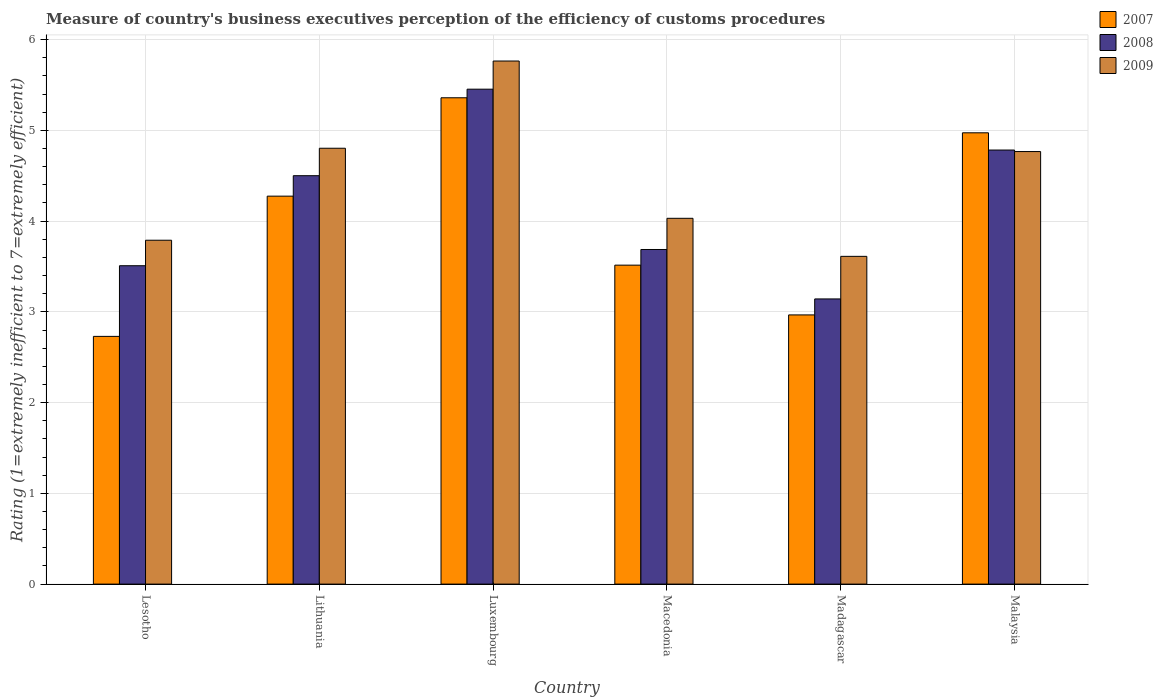How many groups of bars are there?
Make the answer very short. 6. Are the number of bars per tick equal to the number of legend labels?
Ensure brevity in your answer.  Yes. Are the number of bars on each tick of the X-axis equal?
Offer a terse response. Yes. How many bars are there on the 3rd tick from the left?
Keep it short and to the point. 3. What is the label of the 5th group of bars from the left?
Give a very brief answer. Madagascar. In how many cases, is the number of bars for a given country not equal to the number of legend labels?
Keep it short and to the point. 0. What is the rating of the efficiency of customs procedure in 2008 in Malaysia?
Your answer should be compact. 4.78. Across all countries, what is the maximum rating of the efficiency of customs procedure in 2008?
Ensure brevity in your answer.  5.45. Across all countries, what is the minimum rating of the efficiency of customs procedure in 2009?
Offer a terse response. 3.61. In which country was the rating of the efficiency of customs procedure in 2009 maximum?
Provide a short and direct response. Luxembourg. In which country was the rating of the efficiency of customs procedure in 2007 minimum?
Your answer should be compact. Lesotho. What is the total rating of the efficiency of customs procedure in 2007 in the graph?
Ensure brevity in your answer.  23.82. What is the difference between the rating of the efficiency of customs procedure in 2007 in Lithuania and that in Malaysia?
Offer a very short reply. -0.7. What is the difference between the rating of the efficiency of customs procedure in 2008 in Madagascar and the rating of the efficiency of customs procedure in 2009 in Lesotho?
Your answer should be compact. -0.65. What is the average rating of the efficiency of customs procedure in 2008 per country?
Ensure brevity in your answer.  4.18. What is the difference between the rating of the efficiency of customs procedure of/in 2007 and rating of the efficiency of customs procedure of/in 2008 in Macedonia?
Provide a short and direct response. -0.17. In how many countries, is the rating of the efficiency of customs procedure in 2008 greater than 0.8?
Ensure brevity in your answer.  6. What is the ratio of the rating of the efficiency of customs procedure in 2008 in Luxembourg to that in Madagascar?
Your response must be concise. 1.74. Is the rating of the efficiency of customs procedure in 2007 in Macedonia less than that in Malaysia?
Offer a very short reply. Yes. What is the difference between the highest and the second highest rating of the efficiency of customs procedure in 2008?
Provide a short and direct response. -0.28. What is the difference between the highest and the lowest rating of the efficiency of customs procedure in 2007?
Provide a short and direct response. 2.63. In how many countries, is the rating of the efficiency of customs procedure in 2008 greater than the average rating of the efficiency of customs procedure in 2008 taken over all countries?
Your answer should be very brief. 3. What does the 1st bar from the right in Macedonia represents?
Your response must be concise. 2009. Is it the case that in every country, the sum of the rating of the efficiency of customs procedure in 2008 and rating of the efficiency of customs procedure in 2009 is greater than the rating of the efficiency of customs procedure in 2007?
Your answer should be very brief. Yes. How many bars are there?
Ensure brevity in your answer.  18. Are all the bars in the graph horizontal?
Offer a very short reply. No. What is the difference between two consecutive major ticks on the Y-axis?
Ensure brevity in your answer.  1. Are the values on the major ticks of Y-axis written in scientific E-notation?
Provide a short and direct response. No. Does the graph contain any zero values?
Your response must be concise. No. Does the graph contain grids?
Ensure brevity in your answer.  Yes. Where does the legend appear in the graph?
Your response must be concise. Top right. How many legend labels are there?
Your answer should be very brief. 3. What is the title of the graph?
Your response must be concise. Measure of country's business executives perception of the efficiency of customs procedures. What is the label or title of the Y-axis?
Give a very brief answer. Rating (1=extremely inefficient to 7=extremely efficient). What is the Rating (1=extremely inefficient to 7=extremely efficient) in 2007 in Lesotho?
Your response must be concise. 2.73. What is the Rating (1=extremely inefficient to 7=extremely efficient) of 2008 in Lesotho?
Give a very brief answer. 3.51. What is the Rating (1=extremely inefficient to 7=extremely efficient) of 2009 in Lesotho?
Give a very brief answer. 3.79. What is the Rating (1=extremely inefficient to 7=extremely efficient) in 2007 in Lithuania?
Your answer should be compact. 4.28. What is the Rating (1=extremely inefficient to 7=extremely efficient) of 2008 in Lithuania?
Your response must be concise. 4.5. What is the Rating (1=extremely inefficient to 7=extremely efficient) of 2009 in Lithuania?
Keep it short and to the point. 4.8. What is the Rating (1=extremely inefficient to 7=extremely efficient) of 2007 in Luxembourg?
Your answer should be compact. 5.36. What is the Rating (1=extremely inefficient to 7=extremely efficient) of 2008 in Luxembourg?
Your answer should be compact. 5.45. What is the Rating (1=extremely inefficient to 7=extremely efficient) in 2009 in Luxembourg?
Your answer should be very brief. 5.76. What is the Rating (1=extremely inefficient to 7=extremely efficient) in 2007 in Macedonia?
Your answer should be very brief. 3.51. What is the Rating (1=extremely inefficient to 7=extremely efficient) of 2008 in Macedonia?
Keep it short and to the point. 3.69. What is the Rating (1=extremely inefficient to 7=extremely efficient) of 2009 in Macedonia?
Offer a terse response. 4.03. What is the Rating (1=extremely inefficient to 7=extremely efficient) in 2007 in Madagascar?
Your answer should be compact. 2.97. What is the Rating (1=extremely inefficient to 7=extremely efficient) in 2008 in Madagascar?
Your answer should be compact. 3.14. What is the Rating (1=extremely inefficient to 7=extremely efficient) of 2009 in Madagascar?
Your answer should be compact. 3.61. What is the Rating (1=extremely inefficient to 7=extremely efficient) of 2007 in Malaysia?
Ensure brevity in your answer.  4.97. What is the Rating (1=extremely inefficient to 7=extremely efficient) of 2008 in Malaysia?
Provide a succinct answer. 4.78. What is the Rating (1=extremely inefficient to 7=extremely efficient) in 2009 in Malaysia?
Give a very brief answer. 4.77. Across all countries, what is the maximum Rating (1=extremely inefficient to 7=extremely efficient) of 2007?
Offer a terse response. 5.36. Across all countries, what is the maximum Rating (1=extremely inefficient to 7=extremely efficient) of 2008?
Your answer should be very brief. 5.45. Across all countries, what is the maximum Rating (1=extremely inefficient to 7=extremely efficient) in 2009?
Make the answer very short. 5.76. Across all countries, what is the minimum Rating (1=extremely inefficient to 7=extremely efficient) in 2007?
Offer a very short reply. 2.73. Across all countries, what is the minimum Rating (1=extremely inefficient to 7=extremely efficient) in 2008?
Keep it short and to the point. 3.14. Across all countries, what is the minimum Rating (1=extremely inefficient to 7=extremely efficient) of 2009?
Provide a short and direct response. 3.61. What is the total Rating (1=extremely inefficient to 7=extremely efficient) of 2007 in the graph?
Provide a succinct answer. 23.82. What is the total Rating (1=extremely inefficient to 7=extremely efficient) of 2008 in the graph?
Your answer should be very brief. 25.07. What is the total Rating (1=extremely inefficient to 7=extremely efficient) of 2009 in the graph?
Give a very brief answer. 26.76. What is the difference between the Rating (1=extremely inefficient to 7=extremely efficient) in 2007 in Lesotho and that in Lithuania?
Provide a succinct answer. -1.55. What is the difference between the Rating (1=extremely inefficient to 7=extremely efficient) of 2008 in Lesotho and that in Lithuania?
Your answer should be compact. -0.99. What is the difference between the Rating (1=extremely inefficient to 7=extremely efficient) of 2009 in Lesotho and that in Lithuania?
Make the answer very short. -1.01. What is the difference between the Rating (1=extremely inefficient to 7=extremely efficient) of 2007 in Lesotho and that in Luxembourg?
Your response must be concise. -2.63. What is the difference between the Rating (1=extremely inefficient to 7=extremely efficient) of 2008 in Lesotho and that in Luxembourg?
Ensure brevity in your answer.  -1.95. What is the difference between the Rating (1=extremely inefficient to 7=extremely efficient) of 2009 in Lesotho and that in Luxembourg?
Your answer should be compact. -1.97. What is the difference between the Rating (1=extremely inefficient to 7=extremely efficient) in 2007 in Lesotho and that in Macedonia?
Your answer should be very brief. -0.78. What is the difference between the Rating (1=extremely inefficient to 7=extremely efficient) in 2008 in Lesotho and that in Macedonia?
Provide a short and direct response. -0.18. What is the difference between the Rating (1=extremely inefficient to 7=extremely efficient) of 2009 in Lesotho and that in Macedonia?
Make the answer very short. -0.24. What is the difference between the Rating (1=extremely inefficient to 7=extremely efficient) in 2007 in Lesotho and that in Madagascar?
Ensure brevity in your answer.  -0.24. What is the difference between the Rating (1=extremely inefficient to 7=extremely efficient) of 2008 in Lesotho and that in Madagascar?
Make the answer very short. 0.37. What is the difference between the Rating (1=extremely inefficient to 7=extremely efficient) of 2009 in Lesotho and that in Madagascar?
Your answer should be compact. 0.18. What is the difference between the Rating (1=extremely inefficient to 7=extremely efficient) of 2007 in Lesotho and that in Malaysia?
Offer a terse response. -2.24. What is the difference between the Rating (1=extremely inefficient to 7=extremely efficient) of 2008 in Lesotho and that in Malaysia?
Provide a succinct answer. -1.27. What is the difference between the Rating (1=extremely inefficient to 7=extremely efficient) in 2009 in Lesotho and that in Malaysia?
Keep it short and to the point. -0.98. What is the difference between the Rating (1=extremely inefficient to 7=extremely efficient) in 2007 in Lithuania and that in Luxembourg?
Your response must be concise. -1.08. What is the difference between the Rating (1=extremely inefficient to 7=extremely efficient) of 2008 in Lithuania and that in Luxembourg?
Your response must be concise. -0.95. What is the difference between the Rating (1=extremely inefficient to 7=extremely efficient) of 2009 in Lithuania and that in Luxembourg?
Your answer should be very brief. -0.96. What is the difference between the Rating (1=extremely inefficient to 7=extremely efficient) in 2007 in Lithuania and that in Macedonia?
Your answer should be compact. 0.76. What is the difference between the Rating (1=extremely inefficient to 7=extremely efficient) in 2008 in Lithuania and that in Macedonia?
Ensure brevity in your answer.  0.81. What is the difference between the Rating (1=extremely inefficient to 7=extremely efficient) of 2009 in Lithuania and that in Macedonia?
Make the answer very short. 0.77. What is the difference between the Rating (1=extremely inefficient to 7=extremely efficient) of 2007 in Lithuania and that in Madagascar?
Ensure brevity in your answer.  1.31. What is the difference between the Rating (1=extremely inefficient to 7=extremely efficient) in 2008 in Lithuania and that in Madagascar?
Keep it short and to the point. 1.36. What is the difference between the Rating (1=extremely inefficient to 7=extremely efficient) of 2009 in Lithuania and that in Madagascar?
Give a very brief answer. 1.19. What is the difference between the Rating (1=extremely inefficient to 7=extremely efficient) of 2007 in Lithuania and that in Malaysia?
Your answer should be compact. -0.7. What is the difference between the Rating (1=extremely inefficient to 7=extremely efficient) in 2008 in Lithuania and that in Malaysia?
Ensure brevity in your answer.  -0.28. What is the difference between the Rating (1=extremely inefficient to 7=extremely efficient) of 2009 in Lithuania and that in Malaysia?
Your response must be concise. 0.04. What is the difference between the Rating (1=extremely inefficient to 7=extremely efficient) of 2007 in Luxembourg and that in Macedonia?
Your answer should be compact. 1.84. What is the difference between the Rating (1=extremely inefficient to 7=extremely efficient) of 2008 in Luxembourg and that in Macedonia?
Provide a succinct answer. 1.77. What is the difference between the Rating (1=extremely inefficient to 7=extremely efficient) of 2009 in Luxembourg and that in Macedonia?
Offer a very short reply. 1.73. What is the difference between the Rating (1=extremely inefficient to 7=extremely efficient) of 2007 in Luxembourg and that in Madagascar?
Provide a succinct answer. 2.39. What is the difference between the Rating (1=extremely inefficient to 7=extremely efficient) in 2008 in Luxembourg and that in Madagascar?
Ensure brevity in your answer.  2.31. What is the difference between the Rating (1=extremely inefficient to 7=extremely efficient) in 2009 in Luxembourg and that in Madagascar?
Offer a terse response. 2.15. What is the difference between the Rating (1=extremely inefficient to 7=extremely efficient) of 2007 in Luxembourg and that in Malaysia?
Keep it short and to the point. 0.39. What is the difference between the Rating (1=extremely inefficient to 7=extremely efficient) of 2008 in Luxembourg and that in Malaysia?
Make the answer very short. 0.67. What is the difference between the Rating (1=extremely inefficient to 7=extremely efficient) of 2009 in Luxembourg and that in Malaysia?
Your answer should be very brief. 1. What is the difference between the Rating (1=extremely inefficient to 7=extremely efficient) in 2007 in Macedonia and that in Madagascar?
Keep it short and to the point. 0.55. What is the difference between the Rating (1=extremely inefficient to 7=extremely efficient) in 2008 in Macedonia and that in Madagascar?
Offer a terse response. 0.54. What is the difference between the Rating (1=extremely inefficient to 7=extremely efficient) in 2009 in Macedonia and that in Madagascar?
Provide a succinct answer. 0.42. What is the difference between the Rating (1=extremely inefficient to 7=extremely efficient) of 2007 in Macedonia and that in Malaysia?
Keep it short and to the point. -1.46. What is the difference between the Rating (1=extremely inefficient to 7=extremely efficient) in 2008 in Macedonia and that in Malaysia?
Offer a terse response. -1.1. What is the difference between the Rating (1=extremely inefficient to 7=extremely efficient) in 2009 in Macedonia and that in Malaysia?
Provide a short and direct response. -0.74. What is the difference between the Rating (1=extremely inefficient to 7=extremely efficient) of 2007 in Madagascar and that in Malaysia?
Offer a terse response. -2.01. What is the difference between the Rating (1=extremely inefficient to 7=extremely efficient) in 2008 in Madagascar and that in Malaysia?
Keep it short and to the point. -1.64. What is the difference between the Rating (1=extremely inefficient to 7=extremely efficient) of 2009 in Madagascar and that in Malaysia?
Give a very brief answer. -1.15. What is the difference between the Rating (1=extremely inefficient to 7=extremely efficient) of 2007 in Lesotho and the Rating (1=extremely inefficient to 7=extremely efficient) of 2008 in Lithuania?
Provide a succinct answer. -1.77. What is the difference between the Rating (1=extremely inefficient to 7=extremely efficient) of 2007 in Lesotho and the Rating (1=extremely inefficient to 7=extremely efficient) of 2009 in Lithuania?
Offer a very short reply. -2.07. What is the difference between the Rating (1=extremely inefficient to 7=extremely efficient) in 2008 in Lesotho and the Rating (1=extremely inefficient to 7=extremely efficient) in 2009 in Lithuania?
Give a very brief answer. -1.29. What is the difference between the Rating (1=extremely inefficient to 7=extremely efficient) in 2007 in Lesotho and the Rating (1=extremely inefficient to 7=extremely efficient) in 2008 in Luxembourg?
Give a very brief answer. -2.72. What is the difference between the Rating (1=extremely inefficient to 7=extremely efficient) in 2007 in Lesotho and the Rating (1=extremely inefficient to 7=extremely efficient) in 2009 in Luxembourg?
Your answer should be compact. -3.03. What is the difference between the Rating (1=extremely inefficient to 7=extremely efficient) in 2008 in Lesotho and the Rating (1=extremely inefficient to 7=extremely efficient) in 2009 in Luxembourg?
Your response must be concise. -2.26. What is the difference between the Rating (1=extremely inefficient to 7=extremely efficient) of 2007 in Lesotho and the Rating (1=extremely inefficient to 7=extremely efficient) of 2008 in Macedonia?
Ensure brevity in your answer.  -0.96. What is the difference between the Rating (1=extremely inefficient to 7=extremely efficient) in 2007 in Lesotho and the Rating (1=extremely inefficient to 7=extremely efficient) in 2009 in Macedonia?
Provide a succinct answer. -1.3. What is the difference between the Rating (1=extremely inefficient to 7=extremely efficient) in 2008 in Lesotho and the Rating (1=extremely inefficient to 7=extremely efficient) in 2009 in Macedonia?
Make the answer very short. -0.52. What is the difference between the Rating (1=extremely inefficient to 7=extremely efficient) of 2007 in Lesotho and the Rating (1=extremely inefficient to 7=extremely efficient) of 2008 in Madagascar?
Provide a succinct answer. -0.41. What is the difference between the Rating (1=extremely inefficient to 7=extremely efficient) in 2007 in Lesotho and the Rating (1=extremely inefficient to 7=extremely efficient) in 2009 in Madagascar?
Ensure brevity in your answer.  -0.88. What is the difference between the Rating (1=extremely inefficient to 7=extremely efficient) of 2008 in Lesotho and the Rating (1=extremely inefficient to 7=extremely efficient) of 2009 in Madagascar?
Provide a short and direct response. -0.1. What is the difference between the Rating (1=extremely inefficient to 7=extremely efficient) of 2007 in Lesotho and the Rating (1=extremely inefficient to 7=extremely efficient) of 2008 in Malaysia?
Your answer should be very brief. -2.05. What is the difference between the Rating (1=extremely inefficient to 7=extremely efficient) of 2007 in Lesotho and the Rating (1=extremely inefficient to 7=extremely efficient) of 2009 in Malaysia?
Make the answer very short. -2.04. What is the difference between the Rating (1=extremely inefficient to 7=extremely efficient) of 2008 in Lesotho and the Rating (1=extremely inefficient to 7=extremely efficient) of 2009 in Malaysia?
Make the answer very short. -1.26. What is the difference between the Rating (1=extremely inefficient to 7=extremely efficient) in 2007 in Lithuania and the Rating (1=extremely inefficient to 7=extremely efficient) in 2008 in Luxembourg?
Give a very brief answer. -1.18. What is the difference between the Rating (1=extremely inefficient to 7=extremely efficient) in 2007 in Lithuania and the Rating (1=extremely inefficient to 7=extremely efficient) in 2009 in Luxembourg?
Ensure brevity in your answer.  -1.49. What is the difference between the Rating (1=extremely inefficient to 7=extremely efficient) in 2008 in Lithuania and the Rating (1=extremely inefficient to 7=extremely efficient) in 2009 in Luxembourg?
Your response must be concise. -1.26. What is the difference between the Rating (1=extremely inefficient to 7=extremely efficient) of 2007 in Lithuania and the Rating (1=extremely inefficient to 7=extremely efficient) of 2008 in Macedonia?
Make the answer very short. 0.59. What is the difference between the Rating (1=extremely inefficient to 7=extremely efficient) in 2007 in Lithuania and the Rating (1=extremely inefficient to 7=extremely efficient) in 2009 in Macedonia?
Your answer should be very brief. 0.24. What is the difference between the Rating (1=extremely inefficient to 7=extremely efficient) in 2008 in Lithuania and the Rating (1=extremely inefficient to 7=extremely efficient) in 2009 in Macedonia?
Offer a very short reply. 0.47. What is the difference between the Rating (1=extremely inefficient to 7=extremely efficient) of 2007 in Lithuania and the Rating (1=extremely inefficient to 7=extremely efficient) of 2008 in Madagascar?
Provide a succinct answer. 1.13. What is the difference between the Rating (1=extremely inefficient to 7=extremely efficient) of 2007 in Lithuania and the Rating (1=extremely inefficient to 7=extremely efficient) of 2009 in Madagascar?
Make the answer very short. 0.66. What is the difference between the Rating (1=extremely inefficient to 7=extremely efficient) in 2008 in Lithuania and the Rating (1=extremely inefficient to 7=extremely efficient) in 2009 in Madagascar?
Provide a short and direct response. 0.89. What is the difference between the Rating (1=extremely inefficient to 7=extremely efficient) in 2007 in Lithuania and the Rating (1=extremely inefficient to 7=extremely efficient) in 2008 in Malaysia?
Your answer should be very brief. -0.51. What is the difference between the Rating (1=extremely inefficient to 7=extremely efficient) in 2007 in Lithuania and the Rating (1=extremely inefficient to 7=extremely efficient) in 2009 in Malaysia?
Make the answer very short. -0.49. What is the difference between the Rating (1=extremely inefficient to 7=extremely efficient) of 2008 in Lithuania and the Rating (1=extremely inefficient to 7=extremely efficient) of 2009 in Malaysia?
Offer a terse response. -0.27. What is the difference between the Rating (1=extremely inefficient to 7=extremely efficient) in 2007 in Luxembourg and the Rating (1=extremely inefficient to 7=extremely efficient) in 2008 in Macedonia?
Offer a very short reply. 1.67. What is the difference between the Rating (1=extremely inefficient to 7=extremely efficient) of 2007 in Luxembourg and the Rating (1=extremely inefficient to 7=extremely efficient) of 2009 in Macedonia?
Offer a terse response. 1.33. What is the difference between the Rating (1=extremely inefficient to 7=extremely efficient) in 2008 in Luxembourg and the Rating (1=extremely inefficient to 7=extremely efficient) in 2009 in Macedonia?
Your response must be concise. 1.42. What is the difference between the Rating (1=extremely inefficient to 7=extremely efficient) in 2007 in Luxembourg and the Rating (1=extremely inefficient to 7=extremely efficient) in 2008 in Madagascar?
Your answer should be compact. 2.22. What is the difference between the Rating (1=extremely inefficient to 7=extremely efficient) in 2007 in Luxembourg and the Rating (1=extremely inefficient to 7=extremely efficient) in 2009 in Madagascar?
Provide a succinct answer. 1.75. What is the difference between the Rating (1=extremely inefficient to 7=extremely efficient) of 2008 in Luxembourg and the Rating (1=extremely inefficient to 7=extremely efficient) of 2009 in Madagascar?
Your answer should be very brief. 1.84. What is the difference between the Rating (1=extremely inefficient to 7=extremely efficient) of 2007 in Luxembourg and the Rating (1=extremely inefficient to 7=extremely efficient) of 2008 in Malaysia?
Provide a short and direct response. 0.58. What is the difference between the Rating (1=extremely inefficient to 7=extremely efficient) in 2007 in Luxembourg and the Rating (1=extremely inefficient to 7=extremely efficient) in 2009 in Malaysia?
Ensure brevity in your answer.  0.59. What is the difference between the Rating (1=extremely inefficient to 7=extremely efficient) of 2008 in Luxembourg and the Rating (1=extremely inefficient to 7=extremely efficient) of 2009 in Malaysia?
Offer a terse response. 0.69. What is the difference between the Rating (1=extremely inefficient to 7=extremely efficient) of 2007 in Macedonia and the Rating (1=extremely inefficient to 7=extremely efficient) of 2008 in Madagascar?
Make the answer very short. 0.37. What is the difference between the Rating (1=extremely inefficient to 7=extremely efficient) in 2007 in Macedonia and the Rating (1=extremely inefficient to 7=extremely efficient) in 2009 in Madagascar?
Offer a terse response. -0.1. What is the difference between the Rating (1=extremely inefficient to 7=extremely efficient) in 2008 in Macedonia and the Rating (1=extremely inefficient to 7=extremely efficient) in 2009 in Madagascar?
Your answer should be very brief. 0.08. What is the difference between the Rating (1=extremely inefficient to 7=extremely efficient) in 2007 in Macedonia and the Rating (1=extremely inefficient to 7=extremely efficient) in 2008 in Malaysia?
Provide a short and direct response. -1.27. What is the difference between the Rating (1=extremely inefficient to 7=extremely efficient) in 2007 in Macedonia and the Rating (1=extremely inefficient to 7=extremely efficient) in 2009 in Malaysia?
Offer a terse response. -1.25. What is the difference between the Rating (1=extremely inefficient to 7=extremely efficient) of 2008 in Macedonia and the Rating (1=extremely inefficient to 7=extremely efficient) of 2009 in Malaysia?
Your answer should be very brief. -1.08. What is the difference between the Rating (1=extremely inefficient to 7=extremely efficient) in 2007 in Madagascar and the Rating (1=extremely inefficient to 7=extremely efficient) in 2008 in Malaysia?
Your answer should be compact. -1.82. What is the difference between the Rating (1=extremely inefficient to 7=extremely efficient) in 2007 in Madagascar and the Rating (1=extremely inefficient to 7=extremely efficient) in 2009 in Malaysia?
Your answer should be very brief. -1.8. What is the difference between the Rating (1=extremely inefficient to 7=extremely efficient) in 2008 in Madagascar and the Rating (1=extremely inefficient to 7=extremely efficient) in 2009 in Malaysia?
Offer a terse response. -1.62. What is the average Rating (1=extremely inefficient to 7=extremely efficient) of 2007 per country?
Make the answer very short. 3.97. What is the average Rating (1=extremely inefficient to 7=extremely efficient) of 2008 per country?
Provide a succinct answer. 4.18. What is the average Rating (1=extremely inefficient to 7=extremely efficient) in 2009 per country?
Provide a succinct answer. 4.46. What is the difference between the Rating (1=extremely inefficient to 7=extremely efficient) in 2007 and Rating (1=extremely inefficient to 7=extremely efficient) in 2008 in Lesotho?
Offer a terse response. -0.78. What is the difference between the Rating (1=extremely inefficient to 7=extremely efficient) of 2007 and Rating (1=extremely inefficient to 7=extremely efficient) of 2009 in Lesotho?
Offer a terse response. -1.06. What is the difference between the Rating (1=extremely inefficient to 7=extremely efficient) in 2008 and Rating (1=extremely inefficient to 7=extremely efficient) in 2009 in Lesotho?
Offer a terse response. -0.28. What is the difference between the Rating (1=extremely inefficient to 7=extremely efficient) in 2007 and Rating (1=extremely inefficient to 7=extremely efficient) in 2008 in Lithuania?
Ensure brevity in your answer.  -0.23. What is the difference between the Rating (1=extremely inefficient to 7=extremely efficient) in 2007 and Rating (1=extremely inefficient to 7=extremely efficient) in 2009 in Lithuania?
Offer a terse response. -0.53. What is the difference between the Rating (1=extremely inefficient to 7=extremely efficient) of 2008 and Rating (1=extremely inefficient to 7=extremely efficient) of 2009 in Lithuania?
Your answer should be compact. -0.3. What is the difference between the Rating (1=extremely inefficient to 7=extremely efficient) in 2007 and Rating (1=extremely inefficient to 7=extremely efficient) in 2008 in Luxembourg?
Provide a short and direct response. -0.09. What is the difference between the Rating (1=extremely inefficient to 7=extremely efficient) in 2007 and Rating (1=extremely inefficient to 7=extremely efficient) in 2009 in Luxembourg?
Your response must be concise. -0.4. What is the difference between the Rating (1=extremely inefficient to 7=extremely efficient) in 2008 and Rating (1=extremely inefficient to 7=extremely efficient) in 2009 in Luxembourg?
Your answer should be compact. -0.31. What is the difference between the Rating (1=extremely inefficient to 7=extremely efficient) in 2007 and Rating (1=extremely inefficient to 7=extremely efficient) in 2008 in Macedonia?
Offer a terse response. -0.17. What is the difference between the Rating (1=extremely inefficient to 7=extremely efficient) in 2007 and Rating (1=extremely inefficient to 7=extremely efficient) in 2009 in Macedonia?
Your response must be concise. -0.52. What is the difference between the Rating (1=extremely inefficient to 7=extremely efficient) in 2008 and Rating (1=extremely inefficient to 7=extremely efficient) in 2009 in Macedonia?
Your response must be concise. -0.34. What is the difference between the Rating (1=extremely inefficient to 7=extremely efficient) of 2007 and Rating (1=extremely inefficient to 7=extremely efficient) of 2008 in Madagascar?
Make the answer very short. -0.18. What is the difference between the Rating (1=extremely inefficient to 7=extremely efficient) of 2007 and Rating (1=extremely inefficient to 7=extremely efficient) of 2009 in Madagascar?
Offer a very short reply. -0.65. What is the difference between the Rating (1=extremely inefficient to 7=extremely efficient) of 2008 and Rating (1=extremely inefficient to 7=extremely efficient) of 2009 in Madagascar?
Ensure brevity in your answer.  -0.47. What is the difference between the Rating (1=extremely inefficient to 7=extremely efficient) in 2007 and Rating (1=extremely inefficient to 7=extremely efficient) in 2008 in Malaysia?
Offer a terse response. 0.19. What is the difference between the Rating (1=extremely inefficient to 7=extremely efficient) of 2007 and Rating (1=extremely inefficient to 7=extremely efficient) of 2009 in Malaysia?
Provide a short and direct response. 0.21. What is the difference between the Rating (1=extremely inefficient to 7=extremely efficient) of 2008 and Rating (1=extremely inefficient to 7=extremely efficient) of 2009 in Malaysia?
Ensure brevity in your answer.  0.02. What is the ratio of the Rating (1=extremely inefficient to 7=extremely efficient) in 2007 in Lesotho to that in Lithuania?
Offer a terse response. 0.64. What is the ratio of the Rating (1=extremely inefficient to 7=extremely efficient) in 2008 in Lesotho to that in Lithuania?
Ensure brevity in your answer.  0.78. What is the ratio of the Rating (1=extremely inefficient to 7=extremely efficient) in 2009 in Lesotho to that in Lithuania?
Give a very brief answer. 0.79. What is the ratio of the Rating (1=extremely inefficient to 7=extremely efficient) of 2007 in Lesotho to that in Luxembourg?
Ensure brevity in your answer.  0.51. What is the ratio of the Rating (1=extremely inefficient to 7=extremely efficient) of 2008 in Lesotho to that in Luxembourg?
Keep it short and to the point. 0.64. What is the ratio of the Rating (1=extremely inefficient to 7=extremely efficient) of 2009 in Lesotho to that in Luxembourg?
Provide a succinct answer. 0.66. What is the ratio of the Rating (1=extremely inefficient to 7=extremely efficient) of 2007 in Lesotho to that in Macedonia?
Make the answer very short. 0.78. What is the ratio of the Rating (1=extremely inefficient to 7=extremely efficient) of 2008 in Lesotho to that in Macedonia?
Provide a succinct answer. 0.95. What is the ratio of the Rating (1=extremely inefficient to 7=extremely efficient) of 2009 in Lesotho to that in Macedonia?
Make the answer very short. 0.94. What is the ratio of the Rating (1=extremely inefficient to 7=extremely efficient) in 2007 in Lesotho to that in Madagascar?
Keep it short and to the point. 0.92. What is the ratio of the Rating (1=extremely inefficient to 7=extremely efficient) of 2008 in Lesotho to that in Madagascar?
Your response must be concise. 1.12. What is the ratio of the Rating (1=extremely inefficient to 7=extremely efficient) of 2009 in Lesotho to that in Madagascar?
Offer a very short reply. 1.05. What is the ratio of the Rating (1=extremely inefficient to 7=extremely efficient) in 2007 in Lesotho to that in Malaysia?
Provide a short and direct response. 0.55. What is the ratio of the Rating (1=extremely inefficient to 7=extremely efficient) of 2008 in Lesotho to that in Malaysia?
Your response must be concise. 0.73. What is the ratio of the Rating (1=extremely inefficient to 7=extremely efficient) of 2009 in Lesotho to that in Malaysia?
Offer a terse response. 0.8. What is the ratio of the Rating (1=extremely inefficient to 7=extremely efficient) of 2007 in Lithuania to that in Luxembourg?
Your answer should be compact. 0.8. What is the ratio of the Rating (1=extremely inefficient to 7=extremely efficient) of 2008 in Lithuania to that in Luxembourg?
Offer a very short reply. 0.83. What is the ratio of the Rating (1=extremely inefficient to 7=extremely efficient) of 2009 in Lithuania to that in Luxembourg?
Provide a short and direct response. 0.83. What is the ratio of the Rating (1=extremely inefficient to 7=extremely efficient) in 2007 in Lithuania to that in Macedonia?
Offer a terse response. 1.22. What is the ratio of the Rating (1=extremely inefficient to 7=extremely efficient) of 2008 in Lithuania to that in Macedonia?
Provide a short and direct response. 1.22. What is the ratio of the Rating (1=extremely inefficient to 7=extremely efficient) of 2009 in Lithuania to that in Macedonia?
Give a very brief answer. 1.19. What is the ratio of the Rating (1=extremely inefficient to 7=extremely efficient) in 2007 in Lithuania to that in Madagascar?
Your response must be concise. 1.44. What is the ratio of the Rating (1=extremely inefficient to 7=extremely efficient) of 2008 in Lithuania to that in Madagascar?
Offer a very short reply. 1.43. What is the ratio of the Rating (1=extremely inefficient to 7=extremely efficient) in 2009 in Lithuania to that in Madagascar?
Your response must be concise. 1.33. What is the ratio of the Rating (1=extremely inefficient to 7=extremely efficient) of 2007 in Lithuania to that in Malaysia?
Your answer should be very brief. 0.86. What is the ratio of the Rating (1=extremely inefficient to 7=extremely efficient) in 2008 in Lithuania to that in Malaysia?
Ensure brevity in your answer.  0.94. What is the ratio of the Rating (1=extremely inefficient to 7=extremely efficient) of 2009 in Lithuania to that in Malaysia?
Your response must be concise. 1.01. What is the ratio of the Rating (1=extremely inefficient to 7=extremely efficient) in 2007 in Luxembourg to that in Macedonia?
Your answer should be compact. 1.52. What is the ratio of the Rating (1=extremely inefficient to 7=extremely efficient) of 2008 in Luxembourg to that in Macedonia?
Provide a succinct answer. 1.48. What is the ratio of the Rating (1=extremely inefficient to 7=extremely efficient) in 2009 in Luxembourg to that in Macedonia?
Your response must be concise. 1.43. What is the ratio of the Rating (1=extremely inefficient to 7=extremely efficient) in 2007 in Luxembourg to that in Madagascar?
Make the answer very short. 1.81. What is the ratio of the Rating (1=extremely inefficient to 7=extremely efficient) in 2008 in Luxembourg to that in Madagascar?
Make the answer very short. 1.74. What is the ratio of the Rating (1=extremely inefficient to 7=extremely efficient) in 2009 in Luxembourg to that in Madagascar?
Your answer should be very brief. 1.6. What is the ratio of the Rating (1=extremely inefficient to 7=extremely efficient) of 2007 in Luxembourg to that in Malaysia?
Give a very brief answer. 1.08. What is the ratio of the Rating (1=extremely inefficient to 7=extremely efficient) in 2008 in Luxembourg to that in Malaysia?
Provide a succinct answer. 1.14. What is the ratio of the Rating (1=extremely inefficient to 7=extremely efficient) of 2009 in Luxembourg to that in Malaysia?
Offer a terse response. 1.21. What is the ratio of the Rating (1=extremely inefficient to 7=extremely efficient) in 2007 in Macedonia to that in Madagascar?
Give a very brief answer. 1.18. What is the ratio of the Rating (1=extremely inefficient to 7=extremely efficient) in 2008 in Macedonia to that in Madagascar?
Provide a short and direct response. 1.17. What is the ratio of the Rating (1=extremely inefficient to 7=extremely efficient) in 2009 in Macedonia to that in Madagascar?
Offer a terse response. 1.12. What is the ratio of the Rating (1=extremely inefficient to 7=extremely efficient) of 2007 in Macedonia to that in Malaysia?
Offer a terse response. 0.71. What is the ratio of the Rating (1=extremely inefficient to 7=extremely efficient) of 2008 in Macedonia to that in Malaysia?
Keep it short and to the point. 0.77. What is the ratio of the Rating (1=extremely inefficient to 7=extremely efficient) of 2009 in Macedonia to that in Malaysia?
Give a very brief answer. 0.85. What is the ratio of the Rating (1=extremely inefficient to 7=extremely efficient) of 2007 in Madagascar to that in Malaysia?
Your answer should be compact. 0.6. What is the ratio of the Rating (1=extremely inefficient to 7=extremely efficient) of 2008 in Madagascar to that in Malaysia?
Offer a very short reply. 0.66. What is the ratio of the Rating (1=extremely inefficient to 7=extremely efficient) in 2009 in Madagascar to that in Malaysia?
Give a very brief answer. 0.76. What is the difference between the highest and the second highest Rating (1=extremely inefficient to 7=extremely efficient) in 2007?
Your answer should be very brief. 0.39. What is the difference between the highest and the second highest Rating (1=extremely inefficient to 7=extremely efficient) of 2008?
Keep it short and to the point. 0.67. What is the difference between the highest and the lowest Rating (1=extremely inefficient to 7=extremely efficient) in 2007?
Provide a short and direct response. 2.63. What is the difference between the highest and the lowest Rating (1=extremely inefficient to 7=extremely efficient) in 2008?
Make the answer very short. 2.31. What is the difference between the highest and the lowest Rating (1=extremely inefficient to 7=extremely efficient) of 2009?
Offer a very short reply. 2.15. 